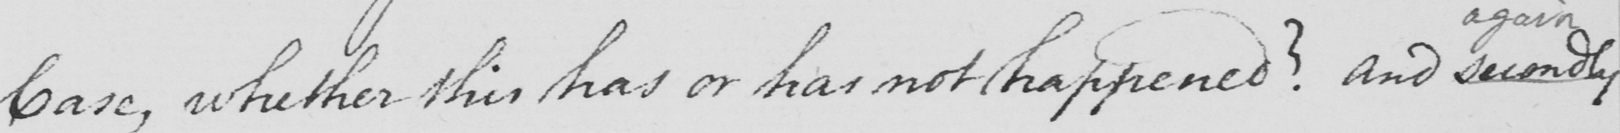Can you read and transcribe this handwriting? Case , whether this has or has not happened ?  and secondly 